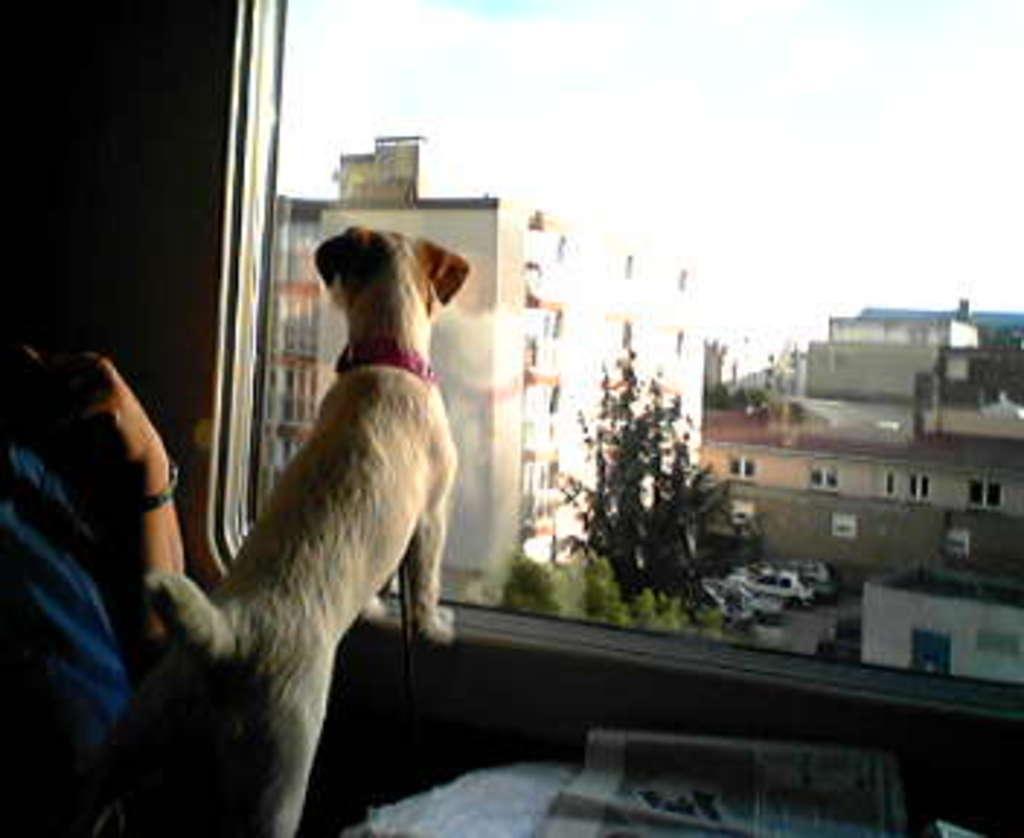How would you summarize this image in a sentence or two? On the left side of the image there is a person. There is a dog. In front of them there is a table and on top of it there is a new paper. There is a glass window through which we can see buildings, trees and sky. 